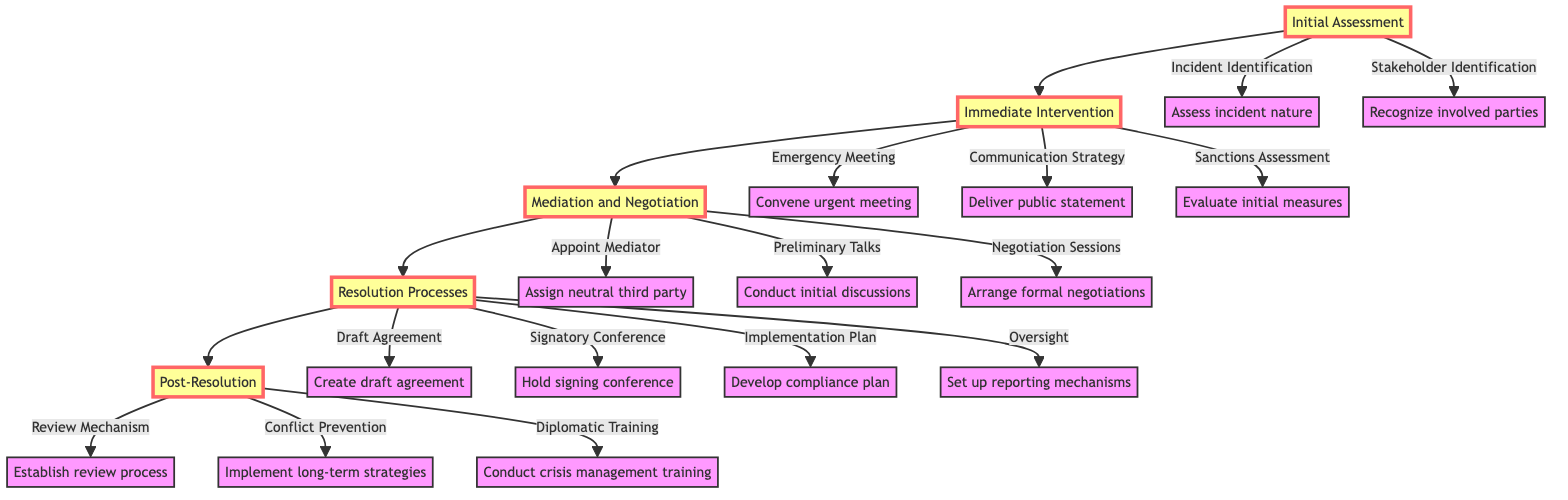What are the first two steps in the pathway? The first two steps in the pathway, as seen from the diagram, are "Incident Identification" and "Stakeholder Identification" under the "Initial Assessment" stage.
Answer: Incident Identification, Stakeholder Identification How many main stages are in the pathway? By counting the main stages listed in the diagram, we find that there are five main stages: Initial Assessment, Immediate Intervention, Mediation and Negotiation, Resolution Processes, and Post-Resolution.
Answer: Five What is the output of the Immediate Intervention stage? The Immediate Intervention stage combines three actions: "Emergency Meeting," "Communication Strategy," and "Sanctions Assessment." These actions are outputs from the Immediate Intervention stage connected to it.
Answer: Emergency Meeting, Communication Strategy, Sanctions Assessment Which step follows Mediation and Negotiation? The step that directly follows the Mediation and Negotiation stage in the flow of the diagram is the Resolution Processes stage, reflecting the order of intervention and resolution in the pathway.
Answer: Resolution Processes What is the purpose of the Review Mechanism in Post-Resolution? The Review Mechanism is intended to establish a process evaluating the effectiveness of the resolution over time, ensuring that the agreements are functioning as intended.
Answer: Establish review process How does the Communication Strategy relate to Emergency Meeting? The Communication Strategy follows the Emergency Meeting in the Immediate Intervention stage, indicating that after convening the meeting, a communication plan is crucial to address the incident publicly.
Answer: Communication Strategy follows Emergency Meeting Which action involves the assignment of a third party? The action involving the assignment of a third party is "Appointment Of Mediator," as indicated in the Mediation and Negotiation stage, where a neutral mediator is assigned to facilitate discussions.
Answer: Appointment Of Mediator What is the final step in the pathway? The final step indicated in the pathway is "Diplomatic Training," which signifies the ongoing educational efforts for future prevention after the resolution processes are completed.
Answer: Diplomatic Training 